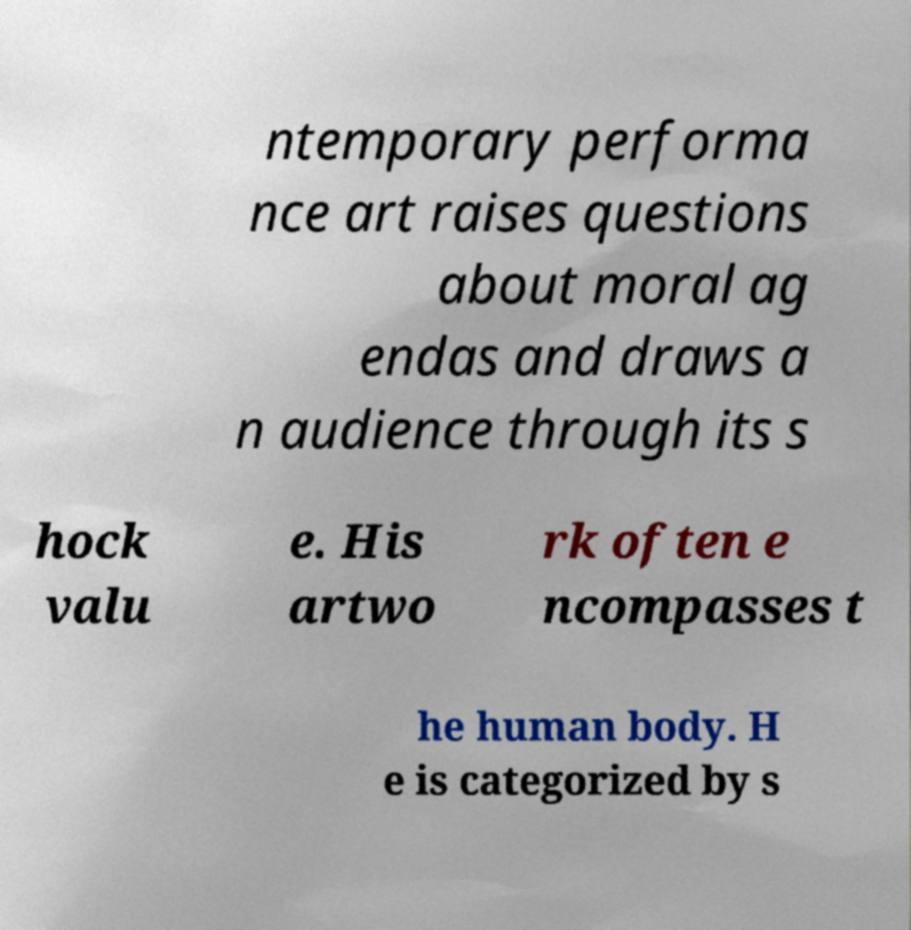Could you assist in decoding the text presented in this image and type it out clearly? ntemporary performa nce art raises questions about moral ag endas and draws a n audience through its s hock valu e. His artwo rk often e ncompasses t he human body. H e is categorized by s 